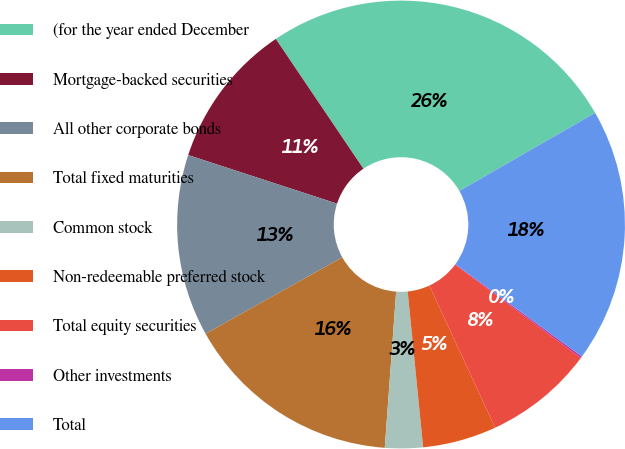Convert chart to OTSL. <chart><loc_0><loc_0><loc_500><loc_500><pie_chart><fcel>(for the year ended December<fcel>Mortgage-backed securities<fcel>All other corporate bonds<fcel>Total fixed maturities<fcel>Common stock<fcel>Non-redeemable preferred stock<fcel>Total equity securities<fcel>Other investments<fcel>Total<nl><fcel>26.14%<fcel>10.53%<fcel>13.13%<fcel>15.73%<fcel>2.73%<fcel>5.33%<fcel>7.93%<fcel>0.13%<fcel>18.34%<nl></chart> 